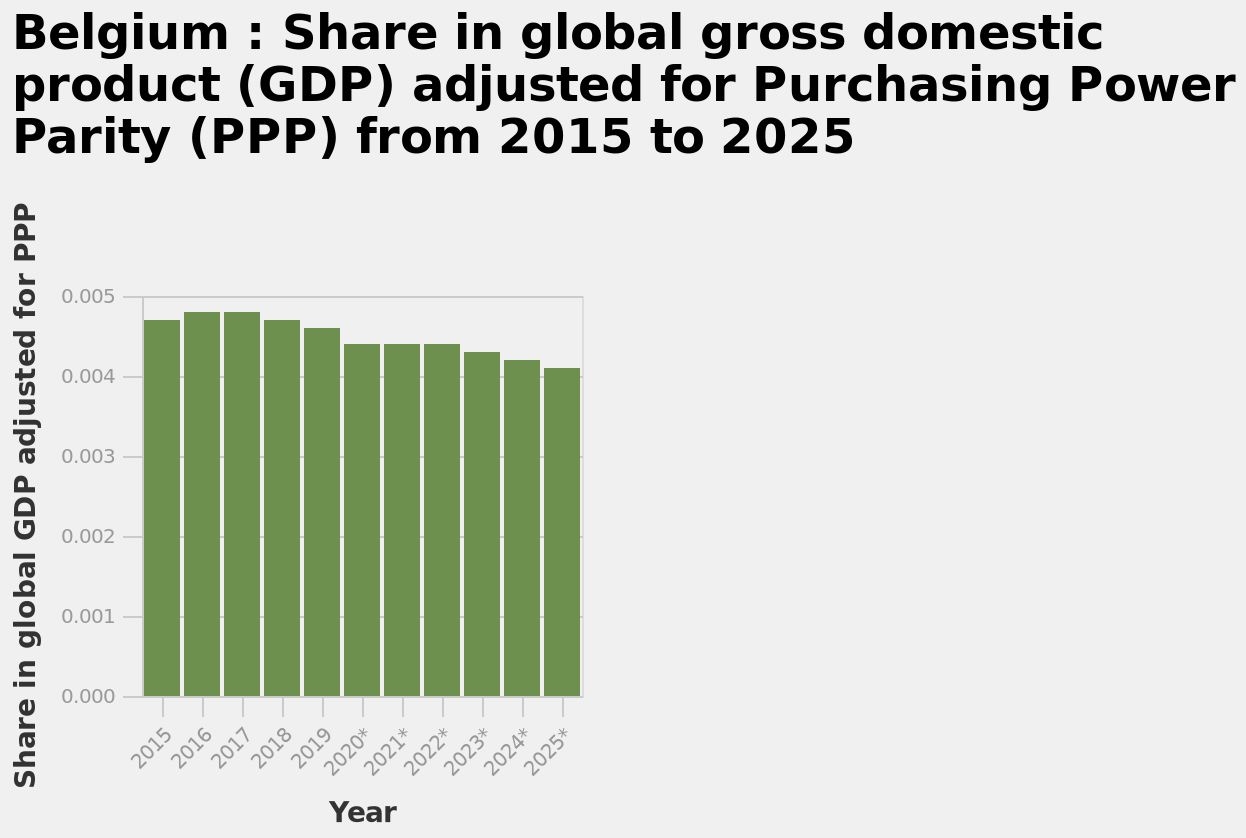<image>
What is the name of the bar diagram? The name of the bar diagram is Belgium. Does Belgium's global GDP share fluctuate at any point during the 10-year period? No, Belgium's global GDP share consistently declines over the entire 10-year period shown on the chart. 